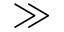Convert formula to latex. <formula><loc_0><loc_0><loc_500><loc_500>\gg</formula> 